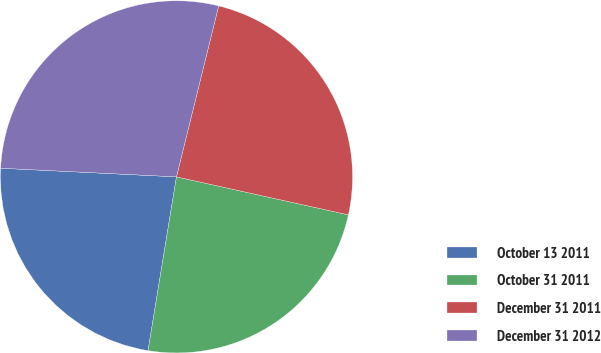<chart> <loc_0><loc_0><loc_500><loc_500><pie_chart><fcel>October 13 2011<fcel>October 31 2011<fcel>December 31 2011<fcel>December 31 2012<nl><fcel>23.2%<fcel>24.12%<fcel>24.61%<fcel>28.07%<nl></chart> 